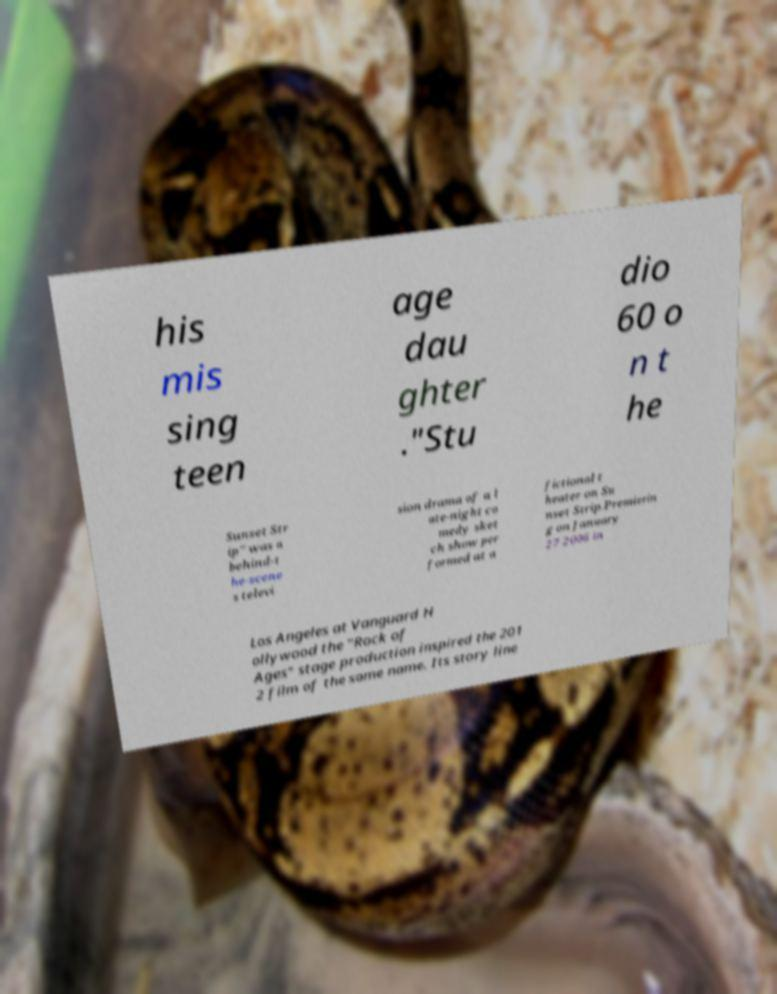I need the written content from this picture converted into text. Can you do that? his mis sing teen age dau ghter ."Stu dio 60 o n t he Sunset Str ip" was a behind-t he-scene s televi sion drama of a l ate-night co medy sket ch show per formed at a fictional t heater on Su nset Strip.Premierin g on January 27 2006 in Los Angeles at Vanguard H ollywood the "Rock of Ages" stage production inspired the 201 2 film of the same name. Its story line 